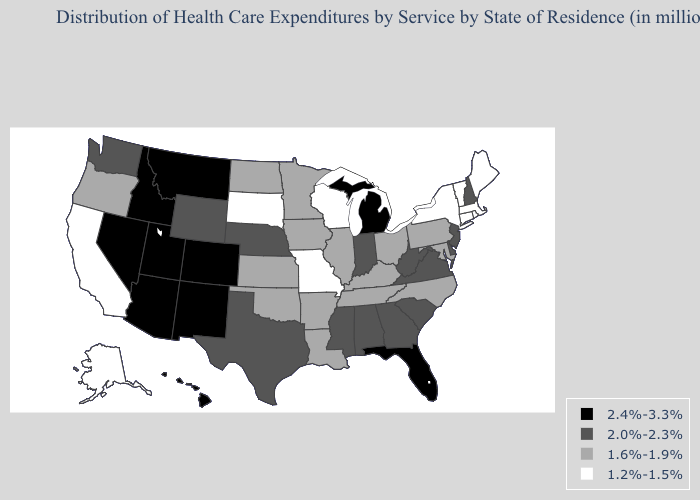Name the states that have a value in the range 2.0%-2.3%?
Concise answer only. Alabama, Delaware, Georgia, Indiana, Mississippi, Nebraska, New Hampshire, New Jersey, South Carolina, Texas, Virginia, Washington, West Virginia, Wyoming. Does Minnesota have the lowest value in the USA?
Keep it brief. No. Name the states that have a value in the range 1.2%-1.5%?
Answer briefly. Alaska, California, Connecticut, Maine, Massachusetts, Missouri, New York, Rhode Island, South Dakota, Vermont, Wisconsin. Does Idaho have a higher value than Florida?
Short answer required. No. Name the states that have a value in the range 2.0%-2.3%?
Give a very brief answer. Alabama, Delaware, Georgia, Indiana, Mississippi, Nebraska, New Hampshire, New Jersey, South Carolina, Texas, Virginia, Washington, West Virginia, Wyoming. What is the lowest value in states that border Florida?
Answer briefly. 2.0%-2.3%. What is the value of Mississippi?
Concise answer only. 2.0%-2.3%. Name the states that have a value in the range 2.4%-3.3%?
Quick response, please. Arizona, Colorado, Florida, Hawaii, Idaho, Michigan, Montana, Nevada, New Mexico, Utah. Does Connecticut have a lower value than Massachusetts?
Answer briefly. No. Does the first symbol in the legend represent the smallest category?
Be succinct. No. Which states have the highest value in the USA?
Keep it brief. Arizona, Colorado, Florida, Hawaii, Idaho, Michigan, Montana, Nevada, New Mexico, Utah. Among the states that border Idaho , which have the lowest value?
Quick response, please. Oregon. Does Michigan have a higher value than Utah?
Write a very short answer. No. What is the highest value in the MidWest ?
Concise answer only. 2.4%-3.3%. Is the legend a continuous bar?
Concise answer only. No. 